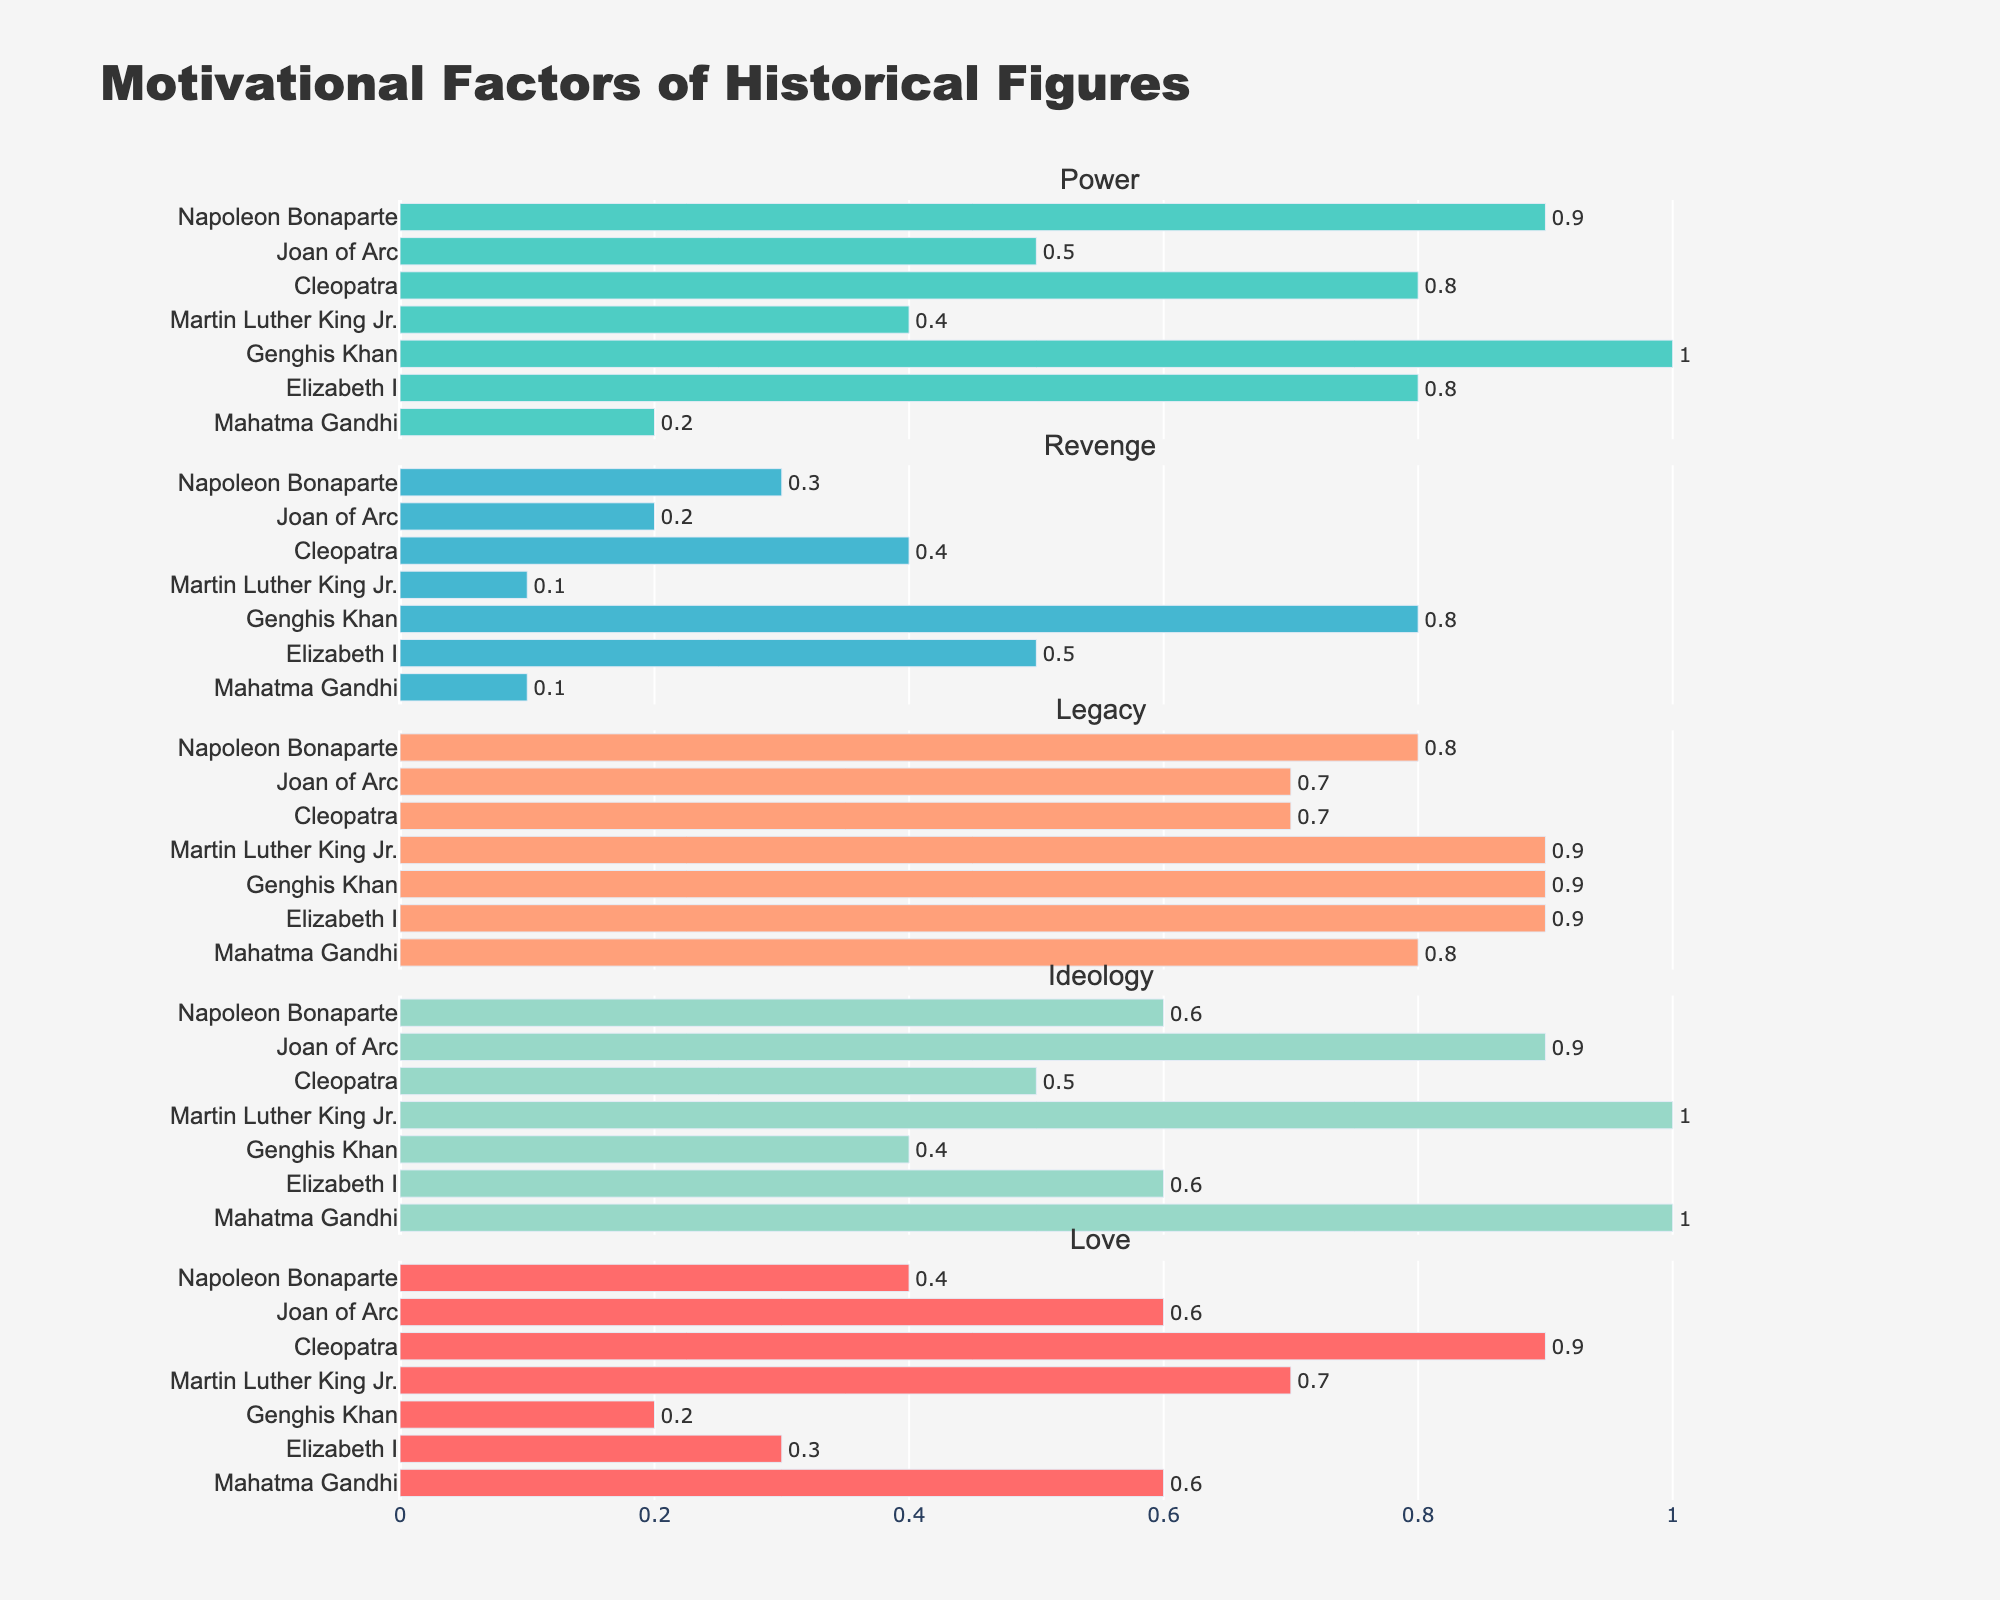What's the highest value for the 'Power' factor and which historical figure does it belong to? By examining the 'Power' subplot, we can see that Genghis Khan has the highest value for the 'Power' factor with a value of 1.0.
Answer: Genghis Khan (1.0) Which historical figure has the lowest score in the 'Revenge' factor? In the 'Revenge' subplot, Martin Luther King Jr. and Mahatma Gandhi both have the lowest score of 0.1 in the 'Revenge' factor.
Answer: Martin Luther King Jr., Mahatma Gandhi (0.1) What's the combined value of the 'Legacy' factor for Cleopatra and Elizabeth I? Refer to the 'Legacy' subplot: Cleopatra has a value of 0.7 and Elizabeth I has a value of 0.9. Summing these values, 0.7 + 0.9 = 1.6.
Answer: 1.6 Which motivational factor is the strongest for Mahatma Gandhi? Looking at Mahatma Gandhi's scores across all subplots, the 'Ideology' factor has the highest value of 1.0.
Answer: Ideology Compare the 'Love' factores of Joan of Arc and Cleopatra. Who has the higher value and by how much? Joan of Arc has a 'Love' factor value of 0.6 and Cleopatra has a value of 0.9. The difference is 0.9 - 0.6 = 0.3, so Cleopatra's value is higher by 0.3.
Answer: Cleopatra by 0.3 What is the average score in the 'Power' factor across all historical figures? Add the 'Power' values: 0.9 (Napoleon Bonaparte) + 0.5 (Joan of Arc) + 0.8 (Cleopatra) + 0.4 (Martin Luther King Jr.) + 1.0 (Genghis Khan) + 0.8 (Elizabeth I) + 0.2 (Mahatma Gandhi) = 4.6. There are 7 figures, so the average is 4.6 / 7 ≈ 0.66.
Answer: 0.66 Which factor has consistent scores below 0.5 for at least 3 historical figures? Examine each subplot to check for values below 0.5: 'Power', 'Legacy', 'Ideology', and 'Love' do not meet the criteria. 'Revenge' has values below 0.5 for Napoleon Bonaparte, Joan of Arc, Martin Luther King Jr., and Mahatma Gandhi (4 figures).
Answer: Revenge What is the title of the entire plot? The title is "Motivational Factors of Historical Figures," located at the top center of the plot.
Answer: Motivational Factors of Historical Figures Which historical figure has the most even distribution of motivational factors without significant highs or lows? By looking at the overall distribution of each subplot, Cleopatra's scores vary but are relatively balanced across all factors.
Answer: Cleopatra 